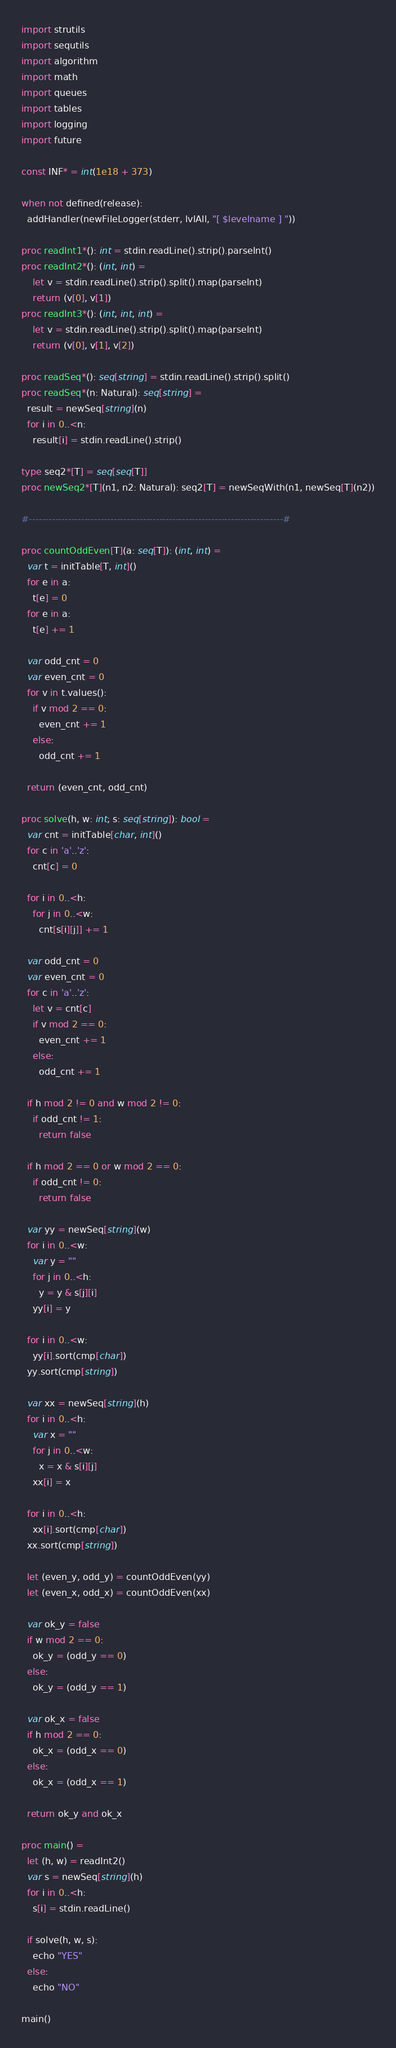<code> <loc_0><loc_0><loc_500><loc_500><_Nim_>import strutils
import sequtils
import algorithm
import math
import queues
import tables
import logging
import future

const INF* = int(1e18 + 373)

when not defined(release):
  addHandler(newFileLogger(stderr, lvlAll, "[ $levelname ] "))

proc readInt1*(): int = stdin.readLine().strip().parseInt()
proc readInt2*(): (int, int) =
    let v = stdin.readLine().strip().split().map(parseInt)
    return (v[0], v[1])
proc readInt3*(): (int, int, int) =
    let v = stdin.readLine().strip().split().map(parseInt)
    return (v[0], v[1], v[2])

proc readSeq*(): seq[string] = stdin.readLine().strip().split()
proc readSeq*(n: Natural): seq[string] =
  result = newSeq[string](n)
  for i in 0..<n:
    result[i] = stdin.readLine().strip()

type seq2*[T] = seq[seq[T]]
proc newSeq2*[T](n1, n2: Natural): seq2[T] = newSeqWith(n1, newSeq[T](n2))

#------------------------------------------------------------------------------#

proc countOddEven[T](a: seq[T]): (int, int) =
  var t = initTable[T, int]()
  for e in a:
    t[e] = 0
  for e in a:
    t[e] += 1

  var odd_cnt = 0
  var even_cnt = 0
  for v in t.values():
    if v mod 2 == 0:
      even_cnt += 1
    else:
      odd_cnt += 1

  return (even_cnt, odd_cnt)

proc solve(h, w: int; s: seq[string]): bool =
  var cnt = initTable[char, int]()
  for c in 'a'..'z':
    cnt[c] = 0

  for i in 0..<h:
    for j in 0..<w:
      cnt[s[i][j]] += 1

  var odd_cnt = 0
  var even_cnt = 0
  for c in 'a'..'z':
    let v = cnt[c]
    if v mod 2 == 0:
      even_cnt += 1
    else:
      odd_cnt += 1

  if h mod 2 != 0 and w mod 2 != 0:
    if odd_cnt != 1:
      return false

  if h mod 2 == 0 or w mod 2 == 0:
    if odd_cnt != 0:
      return false

  var yy = newSeq[string](w)
  for i in 0..<w:
    var y = ""
    for j in 0..<h:
      y = y & s[j][i]
    yy[i] = y

  for i in 0..<w:
    yy[i].sort(cmp[char])
  yy.sort(cmp[string])

  var xx = newSeq[string](h)
  for i in 0..<h:
    var x = ""
    for j in 0..<w:
      x = x & s[i][j]
    xx[i] = x

  for i in 0..<h:
    xx[i].sort(cmp[char])
  xx.sort(cmp[string])

  let (even_y, odd_y) = countOddEven(yy)
  let (even_x, odd_x) = countOddEven(xx)

  var ok_y = false
  if w mod 2 == 0:
    ok_y = (odd_y == 0)
  else:
    ok_y = (odd_y == 1)

  var ok_x = false
  if h mod 2 == 0:
    ok_x = (odd_x == 0)
  else:
    ok_x = (odd_x == 1)

  return ok_y and ok_x

proc main() =
  let (h, w) = readInt2()
  var s = newSeq[string](h)
  for i in 0..<h:
    s[i] = stdin.readLine()

  if solve(h, w, s):
    echo "YES"
  else:
    echo "NO"

main()

</code> 